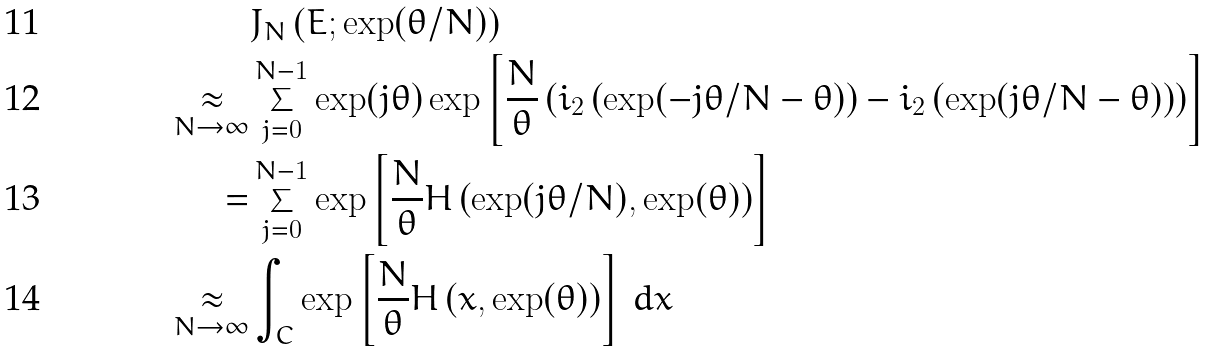Convert formula to latex. <formula><loc_0><loc_0><loc_500><loc_500>& J _ { N } \left ( E ; \exp ( \theta / N ) \right ) \\ \underset { N \to \infty } { \approx } & \sum _ { j = 0 } ^ { N - 1 } \exp ( j \theta ) \exp \left [ \frac { N } { \theta } \left ( \L i _ { 2 } \left ( \exp ( - j \theta / N - \theta ) \right ) - \L i _ { 2 } \left ( \exp ( j \theta / N - \theta ) \right ) \right ) \right ] \\ = & \sum _ { j = 0 } ^ { N - 1 } \exp \left [ \frac { N } { \theta } H \left ( \exp ( j \theta / N ) , \exp ( \theta ) \right ) \right ] \\ \underset { N \to \infty } { \approx } & \int _ { C } \exp \left [ \frac { N } { \theta } H \left ( x , \exp ( \theta ) \right ) \right ] \, d x</formula> 